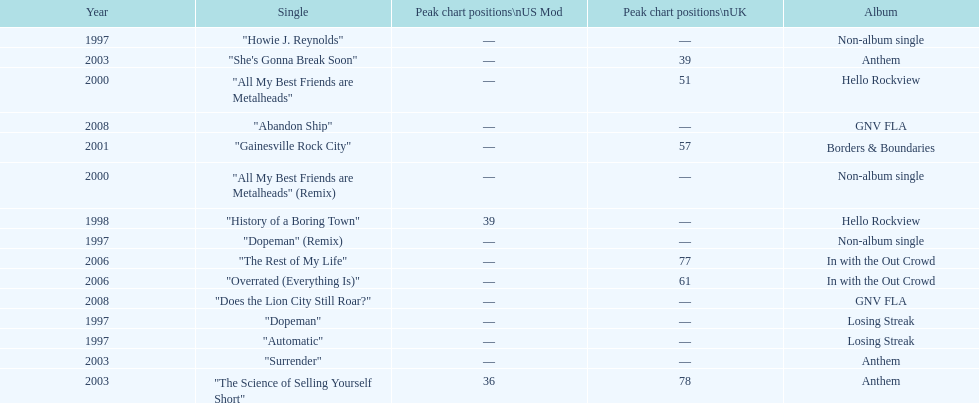How long was it between losing streak almbum and gnv fla in years. 11. 